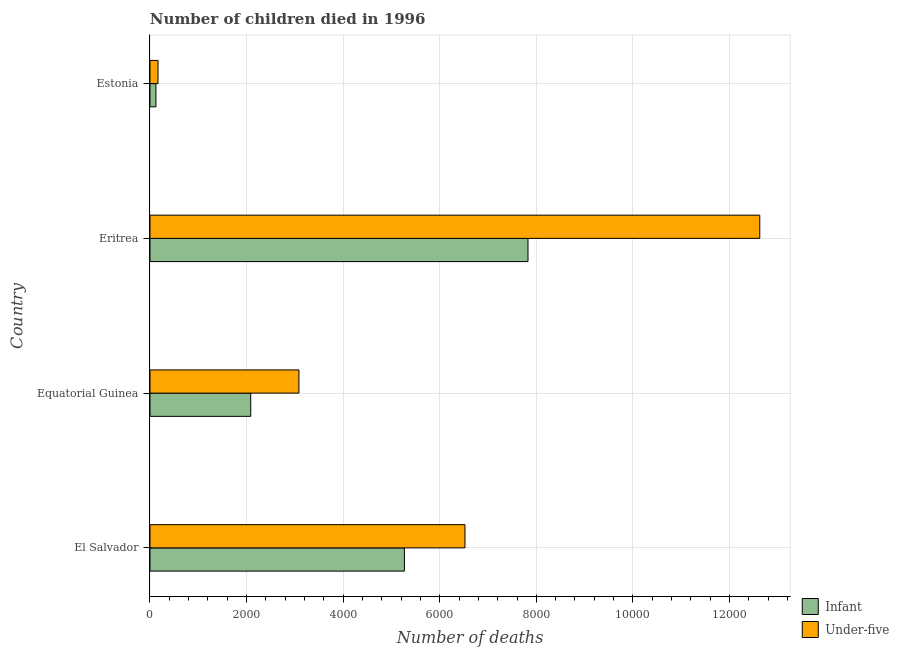Are the number of bars per tick equal to the number of legend labels?
Give a very brief answer. Yes. Are the number of bars on each tick of the Y-axis equal?
Offer a terse response. Yes. What is the label of the 3rd group of bars from the top?
Ensure brevity in your answer.  Equatorial Guinea. In how many cases, is the number of bars for a given country not equal to the number of legend labels?
Provide a short and direct response. 0. What is the number of infant deaths in Estonia?
Ensure brevity in your answer.  123. Across all countries, what is the maximum number of under-five deaths?
Keep it short and to the point. 1.26e+04. Across all countries, what is the minimum number of infant deaths?
Make the answer very short. 123. In which country was the number of infant deaths maximum?
Your response must be concise. Eritrea. In which country was the number of under-five deaths minimum?
Make the answer very short. Estonia. What is the total number of infant deaths in the graph?
Offer a terse response. 1.53e+04. What is the difference between the number of infant deaths in Equatorial Guinea and that in Eritrea?
Make the answer very short. -5741. What is the difference between the number of infant deaths in Eritrea and the number of under-five deaths in Estonia?
Give a very brief answer. 7661. What is the average number of infant deaths per country?
Your response must be concise. 3826. What is the difference between the number of under-five deaths and number of infant deaths in Equatorial Guinea?
Your answer should be compact. 998. In how many countries, is the number of under-five deaths greater than 4800 ?
Make the answer very short. 2. What is the ratio of the number of under-five deaths in Equatorial Guinea to that in Eritrea?
Keep it short and to the point. 0.24. What is the difference between the highest and the second highest number of under-five deaths?
Give a very brief answer. 6104. What is the difference between the highest and the lowest number of under-five deaths?
Your answer should be compact. 1.25e+04. What does the 1st bar from the top in Equatorial Guinea represents?
Keep it short and to the point. Under-five. What does the 2nd bar from the bottom in El Salvador represents?
Your response must be concise. Under-five. Are all the bars in the graph horizontal?
Offer a terse response. Yes. How many countries are there in the graph?
Provide a short and direct response. 4. What is the difference between two consecutive major ticks on the X-axis?
Keep it short and to the point. 2000. How many legend labels are there?
Offer a very short reply. 2. How are the legend labels stacked?
Offer a terse response. Vertical. What is the title of the graph?
Ensure brevity in your answer.  Number of children died in 1996. What is the label or title of the X-axis?
Your answer should be very brief. Number of deaths. What is the Number of deaths in Infant in El Salvador?
Your answer should be compact. 5268. What is the Number of deaths of Under-five in El Salvador?
Ensure brevity in your answer.  6522. What is the Number of deaths of Infant in Equatorial Guinea?
Give a very brief answer. 2086. What is the Number of deaths in Under-five in Equatorial Guinea?
Provide a succinct answer. 3084. What is the Number of deaths in Infant in Eritrea?
Ensure brevity in your answer.  7827. What is the Number of deaths in Under-five in Eritrea?
Your response must be concise. 1.26e+04. What is the Number of deaths in Infant in Estonia?
Give a very brief answer. 123. What is the Number of deaths in Under-five in Estonia?
Give a very brief answer. 166. Across all countries, what is the maximum Number of deaths of Infant?
Your response must be concise. 7827. Across all countries, what is the maximum Number of deaths of Under-five?
Keep it short and to the point. 1.26e+04. Across all countries, what is the minimum Number of deaths in Infant?
Your answer should be very brief. 123. Across all countries, what is the minimum Number of deaths in Under-five?
Provide a short and direct response. 166. What is the total Number of deaths of Infant in the graph?
Make the answer very short. 1.53e+04. What is the total Number of deaths in Under-five in the graph?
Give a very brief answer. 2.24e+04. What is the difference between the Number of deaths in Infant in El Salvador and that in Equatorial Guinea?
Provide a succinct answer. 3182. What is the difference between the Number of deaths of Under-five in El Salvador and that in Equatorial Guinea?
Offer a very short reply. 3438. What is the difference between the Number of deaths in Infant in El Salvador and that in Eritrea?
Offer a very short reply. -2559. What is the difference between the Number of deaths of Under-five in El Salvador and that in Eritrea?
Provide a succinct answer. -6104. What is the difference between the Number of deaths of Infant in El Salvador and that in Estonia?
Keep it short and to the point. 5145. What is the difference between the Number of deaths of Under-five in El Salvador and that in Estonia?
Offer a very short reply. 6356. What is the difference between the Number of deaths in Infant in Equatorial Guinea and that in Eritrea?
Offer a terse response. -5741. What is the difference between the Number of deaths of Under-five in Equatorial Guinea and that in Eritrea?
Keep it short and to the point. -9542. What is the difference between the Number of deaths in Infant in Equatorial Guinea and that in Estonia?
Ensure brevity in your answer.  1963. What is the difference between the Number of deaths in Under-five in Equatorial Guinea and that in Estonia?
Offer a very short reply. 2918. What is the difference between the Number of deaths of Infant in Eritrea and that in Estonia?
Your answer should be compact. 7704. What is the difference between the Number of deaths of Under-five in Eritrea and that in Estonia?
Keep it short and to the point. 1.25e+04. What is the difference between the Number of deaths of Infant in El Salvador and the Number of deaths of Under-five in Equatorial Guinea?
Ensure brevity in your answer.  2184. What is the difference between the Number of deaths of Infant in El Salvador and the Number of deaths of Under-five in Eritrea?
Give a very brief answer. -7358. What is the difference between the Number of deaths in Infant in El Salvador and the Number of deaths in Under-five in Estonia?
Your answer should be very brief. 5102. What is the difference between the Number of deaths of Infant in Equatorial Guinea and the Number of deaths of Under-five in Eritrea?
Your answer should be compact. -1.05e+04. What is the difference between the Number of deaths of Infant in Equatorial Guinea and the Number of deaths of Under-five in Estonia?
Your response must be concise. 1920. What is the difference between the Number of deaths of Infant in Eritrea and the Number of deaths of Under-five in Estonia?
Provide a succinct answer. 7661. What is the average Number of deaths in Infant per country?
Make the answer very short. 3826. What is the average Number of deaths in Under-five per country?
Your answer should be compact. 5599.5. What is the difference between the Number of deaths of Infant and Number of deaths of Under-five in El Salvador?
Your answer should be compact. -1254. What is the difference between the Number of deaths in Infant and Number of deaths in Under-five in Equatorial Guinea?
Ensure brevity in your answer.  -998. What is the difference between the Number of deaths in Infant and Number of deaths in Under-five in Eritrea?
Make the answer very short. -4799. What is the difference between the Number of deaths in Infant and Number of deaths in Under-five in Estonia?
Provide a succinct answer. -43. What is the ratio of the Number of deaths in Infant in El Salvador to that in Equatorial Guinea?
Ensure brevity in your answer.  2.53. What is the ratio of the Number of deaths of Under-five in El Salvador to that in Equatorial Guinea?
Offer a very short reply. 2.11. What is the ratio of the Number of deaths in Infant in El Salvador to that in Eritrea?
Offer a terse response. 0.67. What is the ratio of the Number of deaths in Under-five in El Salvador to that in Eritrea?
Offer a very short reply. 0.52. What is the ratio of the Number of deaths in Infant in El Salvador to that in Estonia?
Offer a very short reply. 42.83. What is the ratio of the Number of deaths of Under-five in El Salvador to that in Estonia?
Your answer should be compact. 39.29. What is the ratio of the Number of deaths in Infant in Equatorial Guinea to that in Eritrea?
Offer a very short reply. 0.27. What is the ratio of the Number of deaths in Under-five in Equatorial Guinea to that in Eritrea?
Keep it short and to the point. 0.24. What is the ratio of the Number of deaths in Infant in Equatorial Guinea to that in Estonia?
Your answer should be very brief. 16.96. What is the ratio of the Number of deaths of Under-five in Equatorial Guinea to that in Estonia?
Give a very brief answer. 18.58. What is the ratio of the Number of deaths in Infant in Eritrea to that in Estonia?
Your response must be concise. 63.63. What is the ratio of the Number of deaths of Under-five in Eritrea to that in Estonia?
Provide a succinct answer. 76.06. What is the difference between the highest and the second highest Number of deaths of Infant?
Your answer should be very brief. 2559. What is the difference between the highest and the second highest Number of deaths in Under-five?
Offer a terse response. 6104. What is the difference between the highest and the lowest Number of deaths of Infant?
Your response must be concise. 7704. What is the difference between the highest and the lowest Number of deaths in Under-five?
Ensure brevity in your answer.  1.25e+04. 